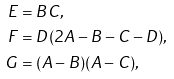Convert formula to latex. <formula><loc_0><loc_0><loc_500><loc_500>E & = B C , \\ F & = D ( 2 A - B - C - D ) , \\ G & = ( A - B ) ( A - C ) ,</formula> 